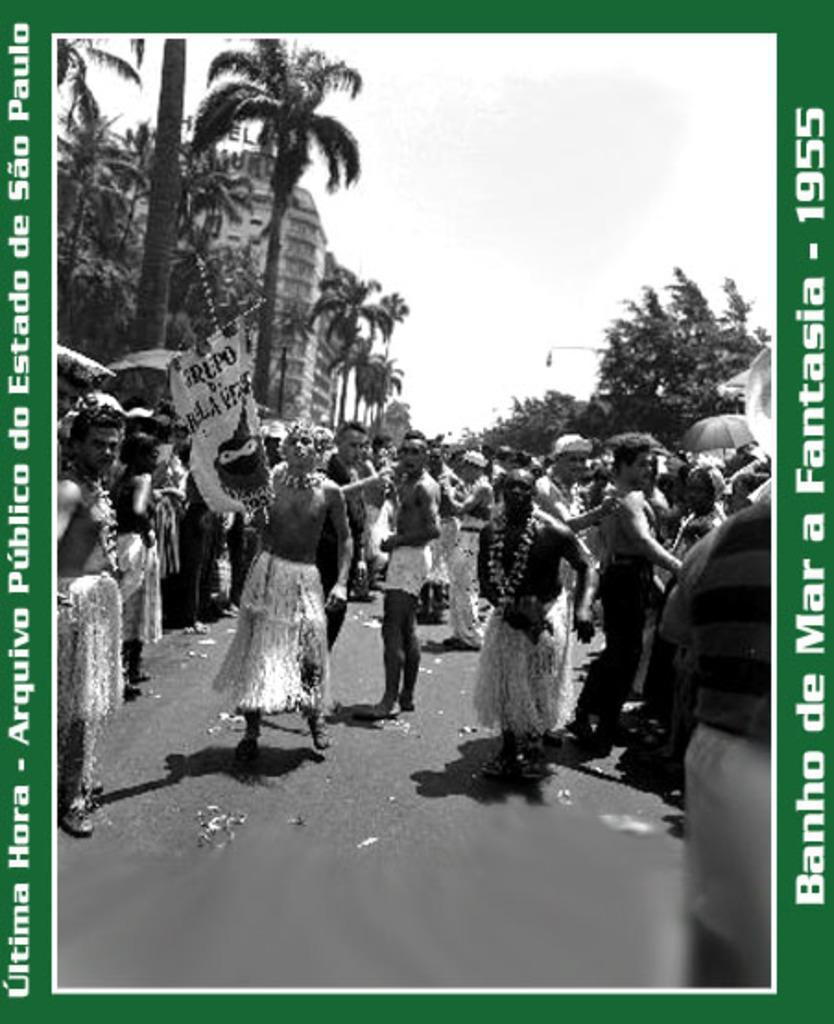Could you give a brief overview of what you see in this image? There is a poster having an image and white color texts. In the image, there are persons on the road. In the background, there are trees, buildings and there are clouds in the sky. And the background of this poster is green in color. 